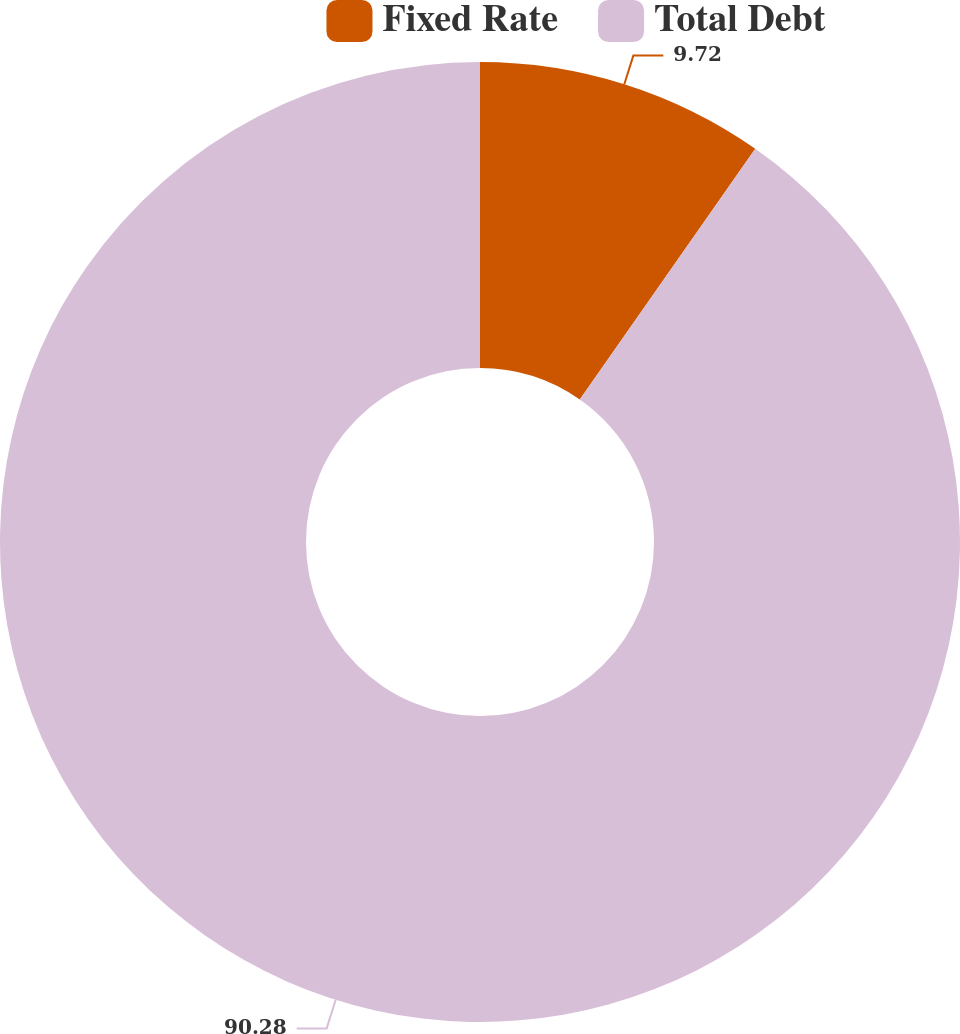Convert chart to OTSL. <chart><loc_0><loc_0><loc_500><loc_500><pie_chart><fcel>Fixed Rate<fcel>Total Debt<nl><fcel>9.72%<fcel>90.28%<nl></chart> 